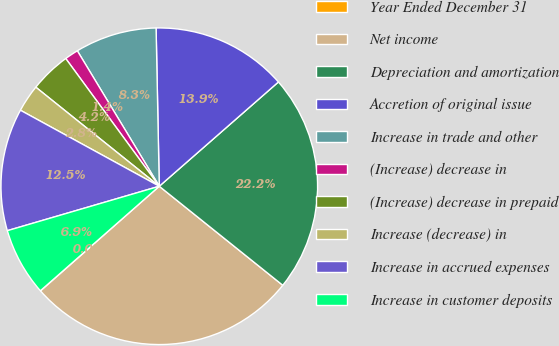<chart> <loc_0><loc_0><loc_500><loc_500><pie_chart><fcel>Year Ended December 31<fcel>Net income<fcel>Depreciation and amortization<fcel>Accretion of original issue<fcel>Increase in trade and other<fcel>(Increase) decrease in<fcel>(Increase) decrease in prepaid<fcel>Increase (decrease) in<fcel>Increase in accrued expenses<fcel>Increase in customer deposits<nl><fcel>0.02%<fcel>27.75%<fcel>22.2%<fcel>13.88%<fcel>8.34%<fcel>1.4%<fcel>4.18%<fcel>2.79%<fcel>12.5%<fcel>6.95%<nl></chart> 